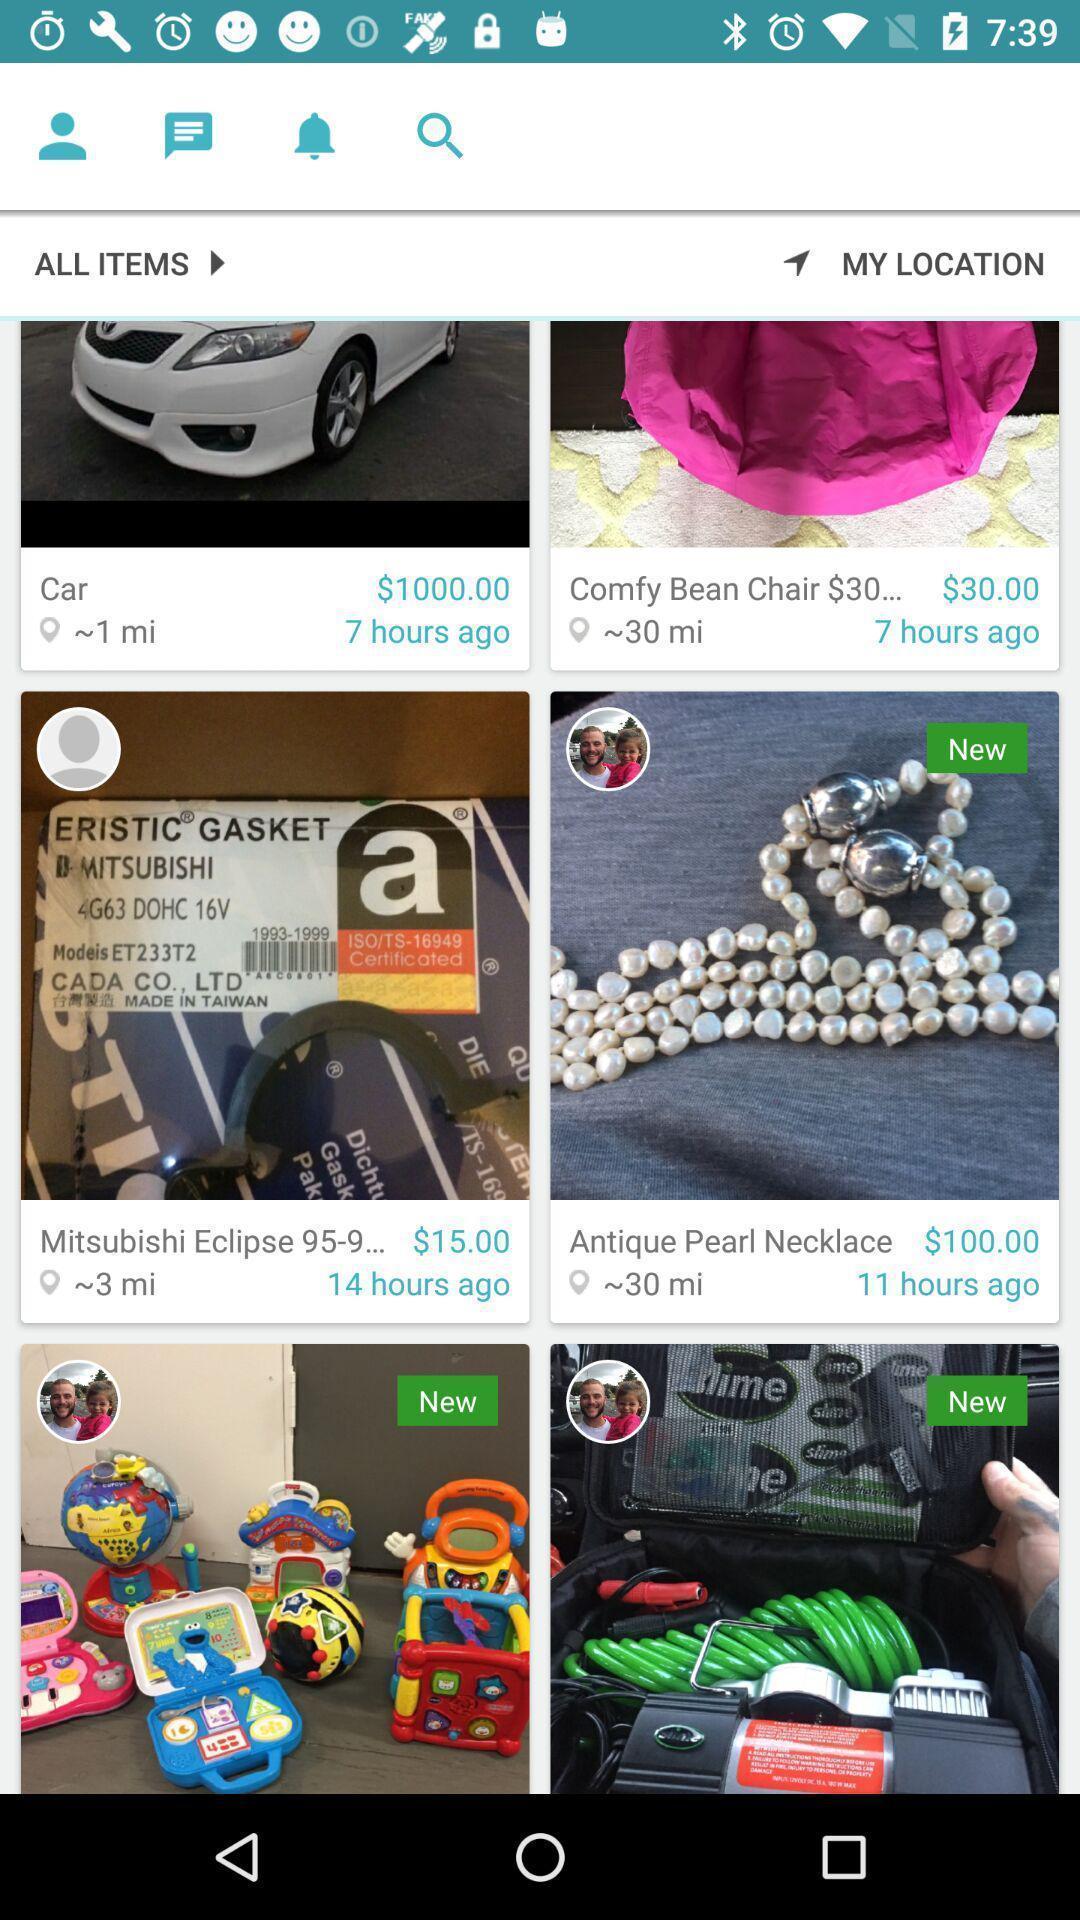What can you discern from this picture? Screen displaying multiple products with price. 